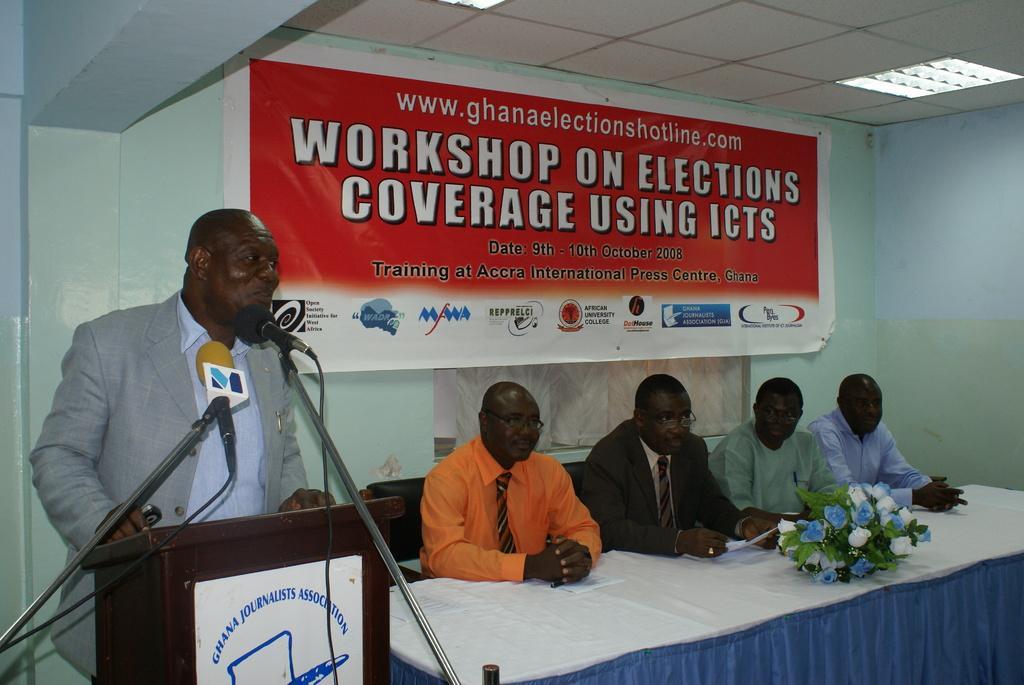In one or two sentences, can you explain what this image depicts? In the image I can see a person who is standing in front of the desk to which there are mice and beside there are some other people sitting in front of the table on which there is a bouquet and behind there is a banner. 